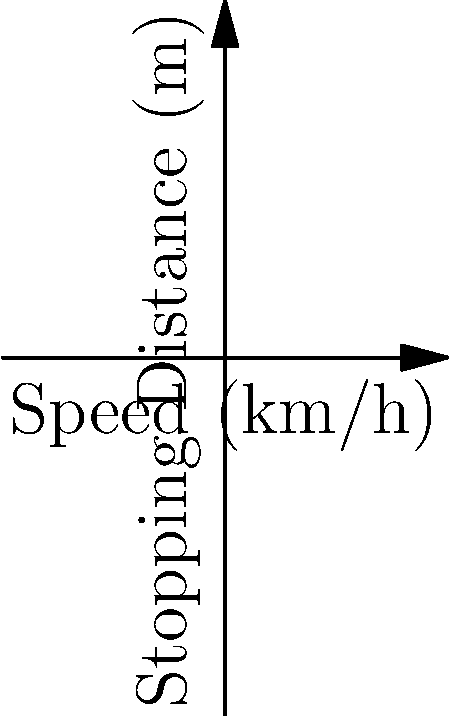You're responding to a multi-vehicle accident on a wet highway where the speed limit is 50 km/h. Based on the graph, what is the approximate safe stopping distance for vehicles traveling at the speed limit on this wet road? How does this compare to the stopping distance on a dry road at the same speed? To solve this problem, we'll follow these steps:

1. Identify the curve for wet road conditions (blue line).
2. Locate the point on the wet road curve corresponding to 50 km/h.
3. Read the stopping distance for this point.
4. Compare with the dry road condition (red line) at the same speed.

Step 1: The blue line represents wet road conditions.

Step 2: We find the point on the blue line corresponding to 50 km/h on the x-axis.

Step 3: Reading from the graph, we can see that for 50 km/h on a wet road, the stopping distance is approximately 45 meters.

Step 4: For comparison, we locate the point on the red line (dry road) at 50 km/h. The stopping distance for a dry road at 50 km/h is approximately 25 meters.

Therefore, the safe stopping distance on a wet road at 50 km/h is about 45 meters, which is significantly longer (about 20 meters more) than on a dry road at the same speed.

This illustrates the importance of adjusting speed based on road conditions, as wet roads require a much longer stopping distance.
Answer: 45 meters on wet road; 20 meters longer than dry road. 